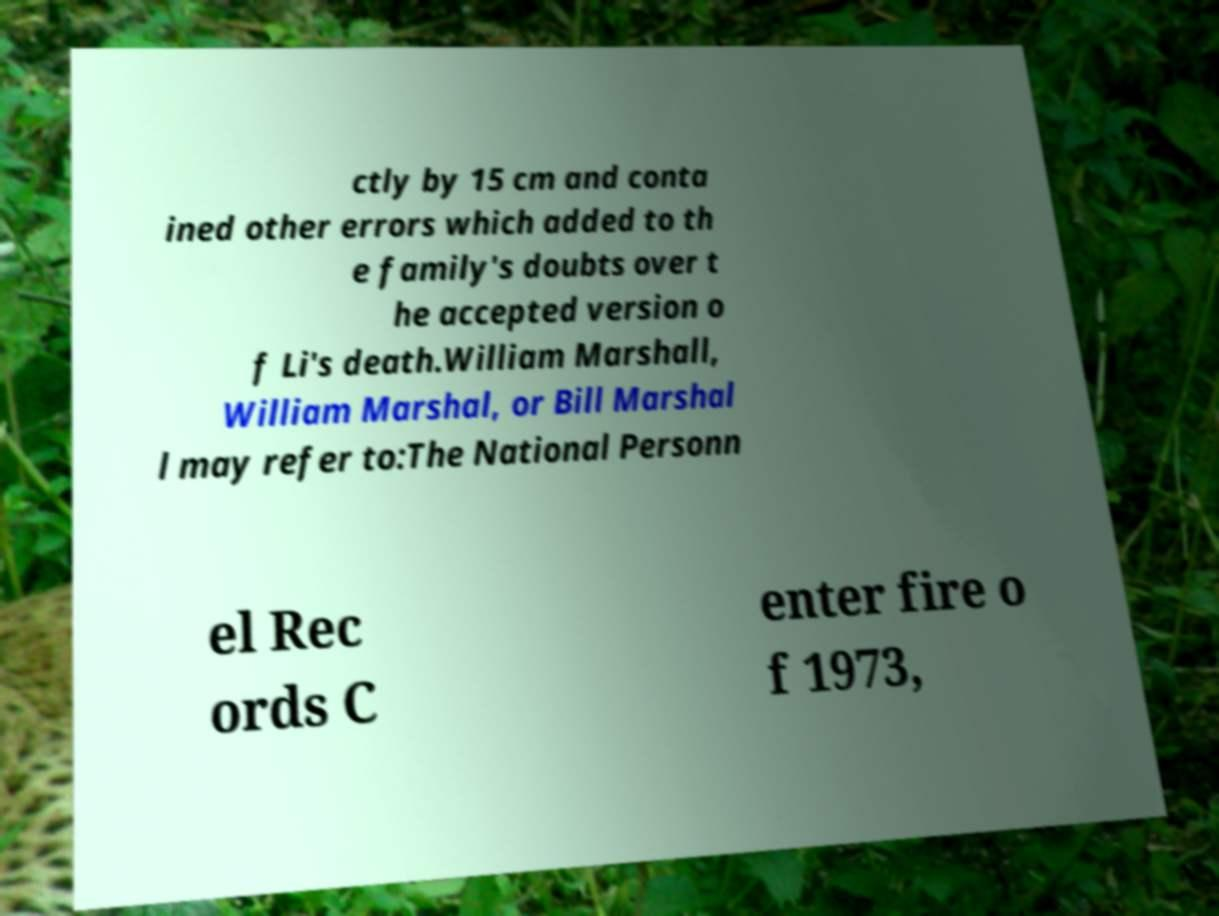Could you assist in decoding the text presented in this image and type it out clearly? ctly by 15 cm and conta ined other errors which added to th e family's doubts over t he accepted version o f Li's death.William Marshall, William Marshal, or Bill Marshal l may refer to:The National Personn el Rec ords C enter fire o f 1973, 